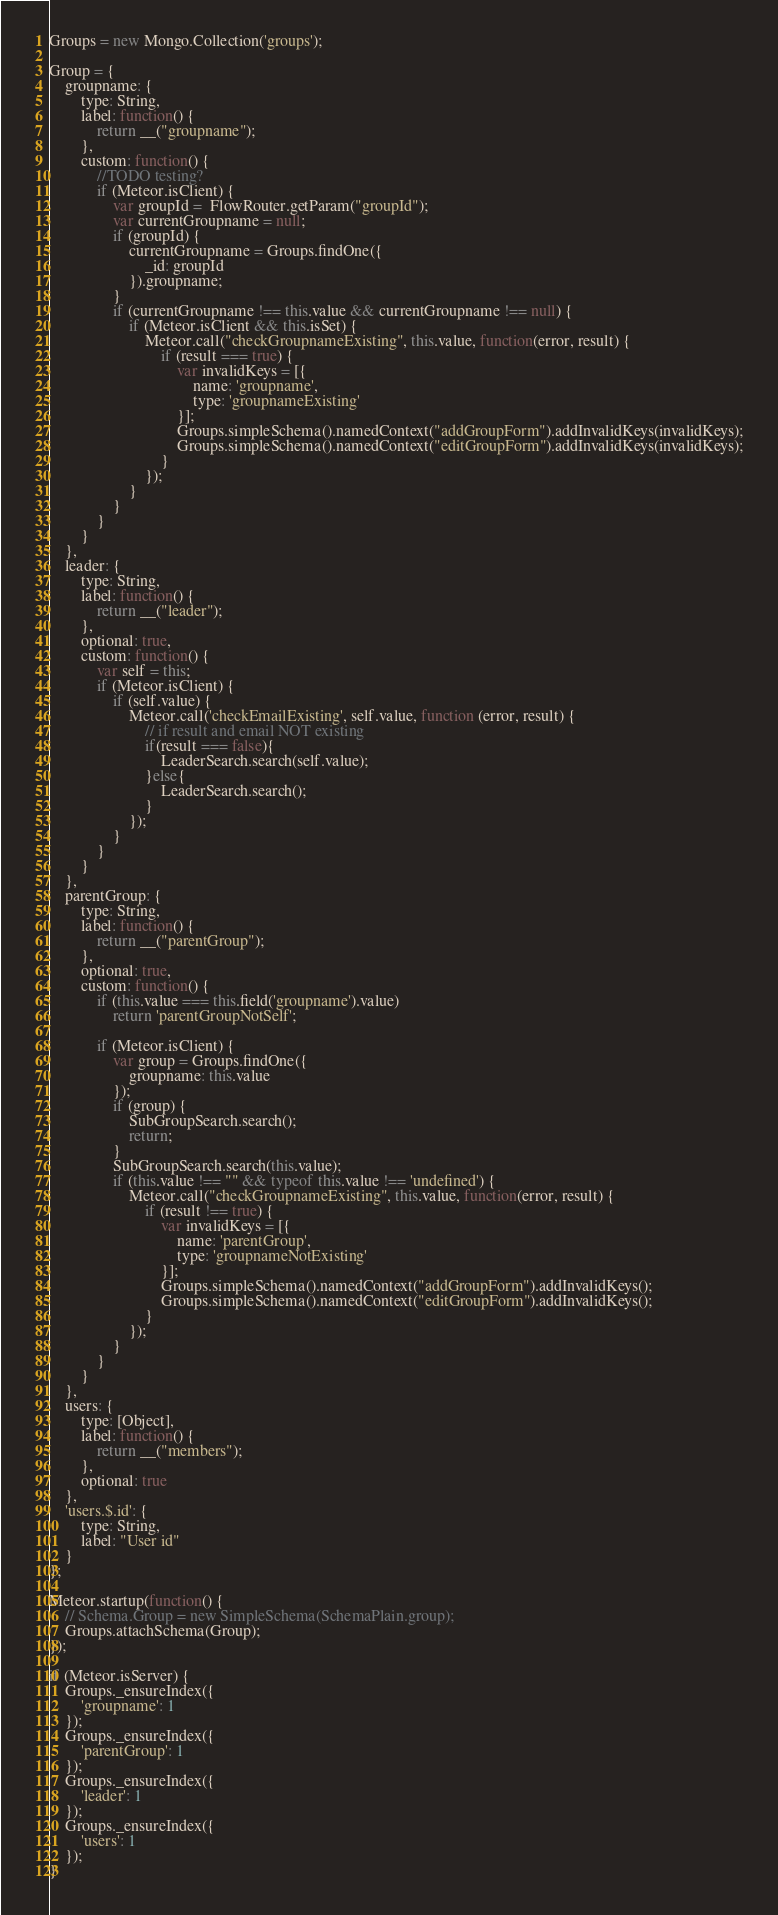Convert code to text. <code><loc_0><loc_0><loc_500><loc_500><_JavaScript_>Groups = new Mongo.Collection('groups');

Group = {
    groupname: {
        type: String,
        label: function() {
            return __("groupname");
        },
        custom: function() {
            //TODO testing?
            if (Meteor.isClient) {
                var groupId =  FlowRouter.getParam("groupId");
                var currentGroupname = null;
                if (groupId) {
                    currentGroupname = Groups.findOne({
                        _id: groupId
                    }).groupname;
                }
                if (currentGroupname !== this.value && currentGroupname !== null) {
                    if (Meteor.isClient && this.isSet) {
                        Meteor.call("checkGroupnameExisting", this.value, function(error, result) {
                            if (result === true) {
                                var invalidKeys = [{
                                    name: 'groupname',
                                    type: 'groupnameExisting'
                                }];
                                Groups.simpleSchema().namedContext("addGroupForm").addInvalidKeys(invalidKeys);
                                Groups.simpleSchema().namedContext("editGroupForm").addInvalidKeys(invalidKeys);
                            }
                        });
                    }
                }
            }
        }
    },
    leader: {
        type: String,
        label: function() {
            return __("leader");
        },
        optional: true,
        custom: function() {
            var self = this;
            if (Meteor.isClient) {
                if (self.value) {
                    Meteor.call('checkEmailExisting', self.value, function (error, result) {
                        // if result and email NOT existing
                        if(result === false){
                            LeaderSearch.search(self.value);
                        }else{
                            LeaderSearch.search();
                        }
                    });
                }
            }
        }
    },
    parentGroup: {
        type: String,
        label: function() {
            return __("parentGroup");
        },
        optional: true,
        custom: function() {
            if (this.value === this.field('groupname').value)
                return 'parentGroupNotSelf';

            if (Meteor.isClient) {
                var group = Groups.findOne({
                    groupname: this.value
                });
                if (group) {
                    SubGroupSearch.search();
                    return;
                }
                SubGroupSearch.search(this.value);
                if (this.value !== "" && typeof this.value !== 'undefined') {
                    Meteor.call("checkGroupnameExisting", this.value, function(error, result) {
                        if (result !== true) {
                            var invalidKeys = [{
                                name: 'parentGroup',
                                type: 'groupnameNotExisting'
                            }];
                            Groups.simpleSchema().namedContext("addGroupForm").addInvalidKeys();
                            Groups.simpleSchema().namedContext("editGroupForm").addInvalidKeys();
                        }
                    });
                }
            }
        }
    },
    users: {
        type: [Object],
        label: function() {
            return __("members");
        },
        optional: true
    },
    'users.$.id': {
        type: String,
        label: "User id"
    }
};

Meteor.startup(function() {
    // Schema.Group = new SimpleSchema(SchemaPlain.group);
    Groups.attachSchema(Group);
});

if (Meteor.isServer) {
    Groups._ensureIndex({
        'groupname': 1
    });
    Groups._ensureIndex({
        'parentGroup': 1
    });
    Groups._ensureIndex({
        'leader': 1
    });
    Groups._ensureIndex({
        'users': 1
    });
}</code> 